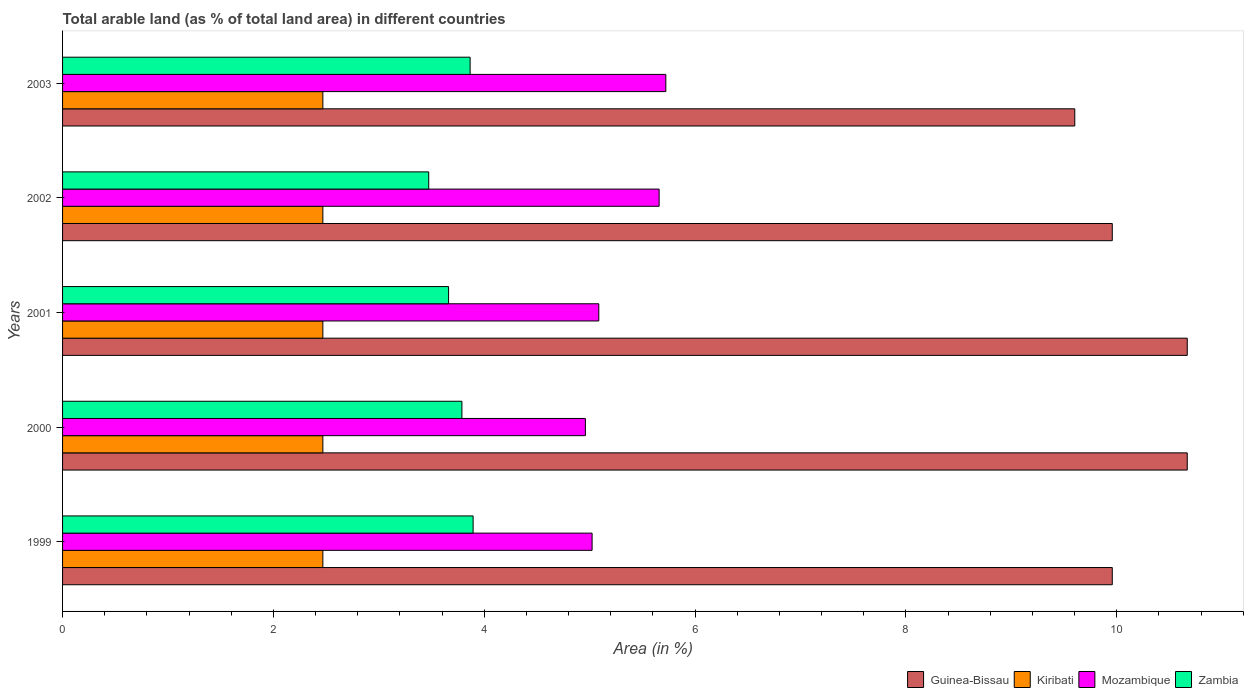How many groups of bars are there?
Give a very brief answer. 5. What is the label of the 5th group of bars from the top?
Provide a succinct answer. 1999. In how many cases, is the number of bars for a given year not equal to the number of legend labels?
Give a very brief answer. 0. What is the percentage of arable land in Kiribati in 2002?
Make the answer very short. 2.47. Across all years, what is the maximum percentage of arable land in Zambia?
Make the answer very short. 3.89. Across all years, what is the minimum percentage of arable land in Mozambique?
Make the answer very short. 4.96. In which year was the percentage of arable land in Zambia maximum?
Provide a short and direct response. 1999. In which year was the percentage of arable land in Zambia minimum?
Offer a very short reply. 2002. What is the total percentage of arable land in Mozambique in the graph?
Your answer should be very brief. 26.45. What is the difference between the percentage of arable land in Kiribati in 2002 and that in 2003?
Make the answer very short. 0. What is the difference between the percentage of arable land in Kiribati in 2000 and the percentage of arable land in Zambia in 1999?
Provide a succinct answer. -1.43. What is the average percentage of arable land in Zambia per year?
Your answer should be very brief. 3.74. In the year 2001, what is the difference between the percentage of arable land in Guinea-Bissau and percentage of arable land in Kiribati?
Ensure brevity in your answer.  8.2. In how many years, is the percentage of arable land in Guinea-Bissau greater than 5.6 %?
Offer a terse response. 5. Is the difference between the percentage of arable land in Guinea-Bissau in 1999 and 2001 greater than the difference between the percentage of arable land in Kiribati in 1999 and 2001?
Your response must be concise. No. What is the difference between the highest and the lowest percentage of arable land in Mozambique?
Give a very brief answer. 0.76. What does the 1st bar from the top in 2002 represents?
Make the answer very short. Zambia. What does the 3rd bar from the bottom in 2000 represents?
Provide a succinct answer. Mozambique. How many bars are there?
Offer a very short reply. 20. Are all the bars in the graph horizontal?
Keep it short and to the point. Yes. How many years are there in the graph?
Your answer should be very brief. 5. What is the difference between two consecutive major ticks on the X-axis?
Make the answer very short. 2. Does the graph contain grids?
Offer a very short reply. No. How are the legend labels stacked?
Provide a succinct answer. Horizontal. What is the title of the graph?
Ensure brevity in your answer.  Total arable land (as % of total land area) in different countries. What is the label or title of the X-axis?
Ensure brevity in your answer.  Area (in %). What is the label or title of the Y-axis?
Ensure brevity in your answer.  Years. What is the Area (in %) of Guinea-Bissau in 1999?
Keep it short and to the point. 9.96. What is the Area (in %) in Kiribati in 1999?
Your answer should be compact. 2.47. What is the Area (in %) of Mozambique in 1999?
Offer a terse response. 5.02. What is the Area (in %) of Zambia in 1999?
Ensure brevity in your answer.  3.89. What is the Area (in %) of Guinea-Bissau in 2000?
Provide a succinct answer. 10.67. What is the Area (in %) in Kiribati in 2000?
Give a very brief answer. 2.47. What is the Area (in %) of Mozambique in 2000?
Give a very brief answer. 4.96. What is the Area (in %) of Zambia in 2000?
Offer a very short reply. 3.79. What is the Area (in %) of Guinea-Bissau in 2001?
Your response must be concise. 10.67. What is the Area (in %) in Kiribati in 2001?
Give a very brief answer. 2.47. What is the Area (in %) in Mozambique in 2001?
Your response must be concise. 5.09. What is the Area (in %) in Zambia in 2001?
Ensure brevity in your answer.  3.66. What is the Area (in %) of Guinea-Bissau in 2002?
Make the answer very short. 9.96. What is the Area (in %) of Kiribati in 2002?
Give a very brief answer. 2.47. What is the Area (in %) in Mozambique in 2002?
Your response must be concise. 5.66. What is the Area (in %) in Zambia in 2002?
Offer a very short reply. 3.47. What is the Area (in %) of Guinea-Bissau in 2003?
Offer a terse response. 9.6. What is the Area (in %) of Kiribati in 2003?
Offer a terse response. 2.47. What is the Area (in %) of Mozambique in 2003?
Your answer should be very brief. 5.72. What is the Area (in %) of Zambia in 2003?
Provide a succinct answer. 3.87. Across all years, what is the maximum Area (in %) of Guinea-Bissau?
Offer a terse response. 10.67. Across all years, what is the maximum Area (in %) in Kiribati?
Make the answer very short. 2.47. Across all years, what is the maximum Area (in %) of Mozambique?
Your response must be concise. 5.72. Across all years, what is the maximum Area (in %) in Zambia?
Ensure brevity in your answer.  3.89. Across all years, what is the minimum Area (in %) of Guinea-Bissau?
Your response must be concise. 9.6. Across all years, what is the minimum Area (in %) in Kiribati?
Provide a succinct answer. 2.47. Across all years, what is the minimum Area (in %) in Mozambique?
Ensure brevity in your answer.  4.96. Across all years, what is the minimum Area (in %) in Zambia?
Your answer should be compact. 3.47. What is the total Area (in %) in Guinea-Bissau in the graph?
Provide a succinct answer. 50.85. What is the total Area (in %) in Kiribati in the graph?
Ensure brevity in your answer.  12.35. What is the total Area (in %) of Mozambique in the graph?
Provide a short and direct response. 26.45. What is the total Area (in %) of Zambia in the graph?
Make the answer very short. 18.68. What is the difference between the Area (in %) in Guinea-Bissau in 1999 and that in 2000?
Ensure brevity in your answer.  -0.71. What is the difference between the Area (in %) in Mozambique in 1999 and that in 2000?
Your answer should be very brief. 0.06. What is the difference between the Area (in %) in Zambia in 1999 and that in 2000?
Ensure brevity in your answer.  0.11. What is the difference between the Area (in %) in Guinea-Bissau in 1999 and that in 2001?
Offer a terse response. -0.71. What is the difference between the Area (in %) of Mozambique in 1999 and that in 2001?
Your answer should be very brief. -0.06. What is the difference between the Area (in %) of Zambia in 1999 and that in 2001?
Provide a succinct answer. 0.23. What is the difference between the Area (in %) of Mozambique in 1999 and that in 2002?
Offer a terse response. -0.64. What is the difference between the Area (in %) in Zambia in 1999 and that in 2002?
Provide a succinct answer. 0.42. What is the difference between the Area (in %) in Guinea-Bissau in 1999 and that in 2003?
Give a very brief answer. 0.36. What is the difference between the Area (in %) in Kiribati in 1999 and that in 2003?
Your response must be concise. 0. What is the difference between the Area (in %) in Mozambique in 1999 and that in 2003?
Your answer should be compact. -0.7. What is the difference between the Area (in %) of Zambia in 1999 and that in 2003?
Your answer should be compact. 0.03. What is the difference between the Area (in %) in Mozambique in 2000 and that in 2001?
Make the answer very short. -0.13. What is the difference between the Area (in %) of Zambia in 2000 and that in 2001?
Ensure brevity in your answer.  0.13. What is the difference between the Area (in %) in Guinea-Bissau in 2000 and that in 2002?
Offer a very short reply. 0.71. What is the difference between the Area (in %) in Kiribati in 2000 and that in 2002?
Provide a succinct answer. 0. What is the difference between the Area (in %) in Mozambique in 2000 and that in 2002?
Your response must be concise. -0.7. What is the difference between the Area (in %) in Zambia in 2000 and that in 2002?
Keep it short and to the point. 0.31. What is the difference between the Area (in %) of Guinea-Bissau in 2000 and that in 2003?
Offer a very short reply. 1.07. What is the difference between the Area (in %) in Mozambique in 2000 and that in 2003?
Offer a terse response. -0.76. What is the difference between the Area (in %) in Zambia in 2000 and that in 2003?
Ensure brevity in your answer.  -0.08. What is the difference between the Area (in %) in Guinea-Bissau in 2001 and that in 2002?
Ensure brevity in your answer.  0.71. What is the difference between the Area (in %) in Mozambique in 2001 and that in 2002?
Provide a short and direct response. -0.57. What is the difference between the Area (in %) of Zambia in 2001 and that in 2002?
Offer a terse response. 0.19. What is the difference between the Area (in %) of Guinea-Bissau in 2001 and that in 2003?
Keep it short and to the point. 1.07. What is the difference between the Area (in %) of Mozambique in 2001 and that in 2003?
Offer a terse response. -0.64. What is the difference between the Area (in %) in Zambia in 2001 and that in 2003?
Provide a short and direct response. -0.2. What is the difference between the Area (in %) in Guinea-Bissau in 2002 and that in 2003?
Ensure brevity in your answer.  0.36. What is the difference between the Area (in %) of Kiribati in 2002 and that in 2003?
Provide a short and direct response. 0. What is the difference between the Area (in %) in Mozambique in 2002 and that in 2003?
Your answer should be compact. -0.06. What is the difference between the Area (in %) of Zambia in 2002 and that in 2003?
Make the answer very short. -0.39. What is the difference between the Area (in %) in Guinea-Bissau in 1999 and the Area (in %) in Kiribati in 2000?
Provide a short and direct response. 7.49. What is the difference between the Area (in %) of Guinea-Bissau in 1999 and the Area (in %) of Mozambique in 2000?
Offer a very short reply. 5. What is the difference between the Area (in %) in Guinea-Bissau in 1999 and the Area (in %) in Zambia in 2000?
Give a very brief answer. 6.17. What is the difference between the Area (in %) in Kiribati in 1999 and the Area (in %) in Mozambique in 2000?
Make the answer very short. -2.49. What is the difference between the Area (in %) of Kiribati in 1999 and the Area (in %) of Zambia in 2000?
Your answer should be very brief. -1.32. What is the difference between the Area (in %) in Mozambique in 1999 and the Area (in %) in Zambia in 2000?
Keep it short and to the point. 1.24. What is the difference between the Area (in %) in Guinea-Bissau in 1999 and the Area (in %) in Kiribati in 2001?
Give a very brief answer. 7.49. What is the difference between the Area (in %) of Guinea-Bissau in 1999 and the Area (in %) of Mozambique in 2001?
Make the answer very short. 4.87. What is the difference between the Area (in %) of Guinea-Bissau in 1999 and the Area (in %) of Zambia in 2001?
Offer a very short reply. 6.3. What is the difference between the Area (in %) in Kiribati in 1999 and the Area (in %) in Mozambique in 2001?
Offer a very short reply. -2.62. What is the difference between the Area (in %) in Kiribati in 1999 and the Area (in %) in Zambia in 2001?
Offer a very short reply. -1.19. What is the difference between the Area (in %) of Mozambique in 1999 and the Area (in %) of Zambia in 2001?
Your response must be concise. 1.36. What is the difference between the Area (in %) of Guinea-Bissau in 1999 and the Area (in %) of Kiribati in 2002?
Offer a very short reply. 7.49. What is the difference between the Area (in %) of Guinea-Bissau in 1999 and the Area (in %) of Mozambique in 2002?
Provide a short and direct response. 4.3. What is the difference between the Area (in %) of Guinea-Bissau in 1999 and the Area (in %) of Zambia in 2002?
Ensure brevity in your answer.  6.48. What is the difference between the Area (in %) in Kiribati in 1999 and the Area (in %) in Mozambique in 2002?
Offer a very short reply. -3.19. What is the difference between the Area (in %) in Kiribati in 1999 and the Area (in %) in Zambia in 2002?
Offer a very short reply. -1. What is the difference between the Area (in %) in Mozambique in 1999 and the Area (in %) in Zambia in 2002?
Ensure brevity in your answer.  1.55. What is the difference between the Area (in %) in Guinea-Bissau in 1999 and the Area (in %) in Kiribati in 2003?
Provide a short and direct response. 7.49. What is the difference between the Area (in %) in Guinea-Bissau in 1999 and the Area (in %) in Mozambique in 2003?
Provide a short and direct response. 4.23. What is the difference between the Area (in %) in Guinea-Bissau in 1999 and the Area (in %) in Zambia in 2003?
Make the answer very short. 6.09. What is the difference between the Area (in %) in Kiribati in 1999 and the Area (in %) in Mozambique in 2003?
Provide a short and direct response. -3.25. What is the difference between the Area (in %) of Kiribati in 1999 and the Area (in %) of Zambia in 2003?
Offer a terse response. -1.4. What is the difference between the Area (in %) of Mozambique in 1999 and the Area (in %) of Zambia in 2003?
Offer a terse response. 1.16. What is the difference between the Area (in %) in Guinea-Bissau in 2000 and the Area (in %) in Kiribati in 2001?
Keep it short and to the point. 8.2. What is the difference between the Area (in %) in Guinea-Bissau in 2000 and the Area (in %) in Mozambique in 2001?
Make the answer very short. 5.58. What is the difference between the Area (in %) in Guinea-Bissau in 2000 and the Area (in %) in Zambia in 2001?
Offer a terse response. 7.01. What is the difference between the Area (in %) of Kiribati in 2000 and the Area (in %) of Mozambique in 2001?
Offer a terse response. -2.62. What is the difference between the Area (in %) of Kiribati in 2000 and the Area (in %) of Zambia in 2001?
Keep it short and to the point. -1.19. What is the difference between the Area (in %) of Mozambique in 2000 and the Area (in %) of Zambia in 2001?
Your response must be concise. 1.3. What is the difference between the Area (in %) in Guinea-Bissau in 2000 and the Area (in %) in Kiribati in 2002?
Offer a very short reply. 8.2. What is the difference between the Area (in %) in Guinea-Bissau in 2000 and the Area (in %) in Mozambique in 2002?
Keep it short and to the point. 5.01. What is the difference between the Area (in %) of Guinea-Bissau in 2000 and the Area (in %) of Zambia in 2002?
Ensure brevity in your answer.  7.2. What is the difference between the Area (in %) of Kiribati in 2000 and the Area (in %) of Mozambique in 2002?
Your answer should be compact. -3.19. What is the difference between the Area (in %) in Kiribati in 2000 and the Area (in %) in Zambia in 2002?
Offer a terse response. -1. What is the difference between the Area (in %) in Mozambique in 2000 and the Area (in %) in Zambia in 2002?
Your response must be concise. 1.49. What is the difference between the Area (in %) of Guinea-Bissau in 2000 and the Area (in %) of Kiribati in 2003?
Give a very brief answer. 8.2. What is the difference between the Area (in %) in Guinea-Bissau in 2000 and the Area (in %) in Mozambique in 2003?
Your answer should be compact. 4.95. What is the difference between the Area (in %) in Guinea-Bissau in 2000 and the Area (in %) in Zambia in 2003?
Provide a short and direct response. 6.8. What is the difference between the Area (in %) in Kiribati in 2000 and the Area (in %) in Mozambique in 2003?
Your answer should be very brief. -3.25. What is the difference between the Area (in %) of Kiribati in 2000 and the Area (in %) of Zambia in 2003?
Provide a succinct answer. -1.4. What is the difference between the Area (in %) in Mozambique in 2000 and the Area (in %) in Zambia in 2003?
Offer a very short reply. 1.09. What is the difference between the Area (in %) of Guinea-Bissau in 2001 and the Area (in %) of Kiribati in 2002?
Provide a short and direct response. 8.2. What is the difference between the Area (in %) in Guinea-Bissau in 2001 and the Area (in %) in Mozambique in 2002?
Your answer should be very brief. 5.01. What is the difference between the Area (in %) of Guinea-Bissau in 2001 and the Area (in %) of Zambia in 2002?
Offer a terse response. 7.2. What is the difference between the Area (in %) in Kiribati in 2001 and the Area (in %) in Mozambique in 2002?
Make the answer very short. -3.19. What is the difference between the Area (in %) in Kiribati in 2001 and the Area (in %) in Zambia in 2002?
Give a very brief answer. -1. What is the difference between the Area (in %) in Mozambique in 2001 and the Area (in %) in Zambia in 2002?
Give a very brief answer. 1.61. What is the difference between the Area (in %) of Guinea-Bissau in 2001 and the Area (in %) of Kiribati in 2003?
Give a very brief answer. 8.2. What is the difference between the Area (in %) in Guinea-Bissau in 2001 and the Area (in %) in Mozambique in 2003?
Offer a terse response. 4.95. What is the difference between the Area (in %) in Guinea-Bissau in 2001 and the Area (in %) in Zambia in 2003?
Offer a terse response. 6.8. What is the difference between the Area (in %) in Kiribati in 2001 and the Area (in %) in Mozambique in 2003?
Provide a succinct answer. -3.25. What is the difference between the Area (in %) of Kiribati in 2001 and the Area (in %) of Zambia in 2003?
Provide a short and direct response. -1.4. What is the difference between the Area (in %) in Mozambique in 2001 and the Area (in %) in Zambia in 2003?
Provide a succinct answer. 1.22. What is the difference between the Area (in %) of Guinea-Bissau in 2002 and the Area (in %) of Kiribati in 2003?
Offer a very short reply. 7.49. What is the difference between the Area (in %) in Guinea-Bissau in 2002 and the Area (in %) in Mozambique in 2003?
Make the answer very short. 4.23. What is the difference between the Area (in %) in Guinea-Bissau in 2002 and the Area (in %) in Zambia in 2003?
Your response must be concise. 6.09. What is the difference between the Area (in %) of Kiribati in 2002 and the Area (in %) of Mozambique in 2003?
Offer a very short reply. -3.25. What is the difference between the Area (in %) in Kiribati in 2002 and the Area (in %) in Zambia in 2003?
Give a very brief answer. -1.4. What is the difference between the Area (in %) in Mozambique in 2002 and the Area (in %) in Zambia in 2003?
Ensure brevity in your answer.  1.79. What is the average Area (in %) in Guinea-Bissau per year?
Your answer should be compact. 10.17. What is the average Area (in %) in Kiribati per year?
Make the answer very short. 2.47. What is the average Area (in %) of Mozambique per year?
Make the answer very short. 5.29. What is the average Area (in %) of Zambia per year?
Offer a terse response. 3.74. In the year 1999, what is the difference between the Area (in %) of Guinea-Bissau and Area (in %) of Kiribati?
Provide a short and direct response. 7.49. In the year 1999, what is the difference between the Area (in %) of Guinea-Bissau and Area (in %) of Mozambique?
Your answer should be very brief. 4.93. In the year 1999, what is the difference between the Area (in %) in Guinea-Bissau and Area (in %) in Zambia?
Your answer should be compact. 6.06. In the year 1999, what is the difference between the Area (in %) in Kiribati and Area (in %) in Mozambique?
Give a very brief answer. -2.55. In the year 1999, what is the difference between the Area (in %) of Kiribati and Area (in %) of Zambia?
Provide a succinct answer. -1.43. In the year 1999, what is the difference between the Area (in %) in Mozambique and Area (in %) in Zambia?
Offer a very short reply. 1.13. In the year 2000, what is the difference between the Area (in %) in Guinea-Bissau and Area (in %) in Kiribati?
Make the answer very short. 8.2. In the year 2000, what is the difference between the Area (in %) in Guinea-Bissau and Area (in %) in Mozambique?
Provide a succinct answer. 5.71. In the year 2000, what is the difference between the Area (in %) in Guinea-Bissau and Area (in %) in Zambia?
Provide a short and direct response. 6.88. In the year 2000, what is the difference between the Area (in %) of Kiribati and Area (in %) of Mozambique?
Make the answer very short. -2.49. In the year 2000, what is the difference between the Area (in %) of Kiribati and Area (in %) of Zambia?
Your answer should be very brief. -1.32. In the year 2000, what is the difference between the Area (in %) in Mozambique and Area (in %) in Zambia?
Give a very brief answer. 1.17. In the year 2001, what is the difference between the Area (in %) in Guinea-Bissau and Area (in %) in Kiribati?
Provide a short and direct response. 8.2. In the year 2001, what is the difference between the Area (in %) in Guinea-Bissau and Area (in %) in Mozambique?
Offer a very short reply. 5.58. In the year 2001, what is the difference between the Area (in %) of Guinea-Bissau and Area (in %) of Zambia?
Keep it short and to the point. 7.01. In the year 2001, what is the difference between the Area (in %) in Kiribati and Area (in %) in Mozambique?
Your answer should be very brief. -2.62. In the year 2001, what is the difference between the Area (in %) in Kiribati and Area (in %) in Zambia?
Your answer should be compact. -1.19. In the year 2001, what is the difference between the Area (in %) of Mozambique and Area (in %) of Zambia?
Provide a short and direct response. 1.43. In the year 2002, what is the difference between the Area (in %) of Guinea-Bissau and Area (in %) of Kiribati?
Make the answer very short. 7.49. In the year 2002, what is the difference between the Area (in %) in Guinea-Bissau and Area (in %) in Mozambique?
Provide a short and direct response. 4.3. In the year 2002, what is the difference between the Area (in %) of Guinea-Bissau and Area (in %) of Zambia?
Offer a very short reply. 6.48. In the year 2002, what is the difference between the Area (in %) of Kiribati and Area (in %) of Mozambique?
Your answer should be very brief. -3.19. In the year 2002, what is the difference between the Area (in %) in Kiribati and Area (in %) in Zambia?
Give a very brief answer. -1. In the year 2002, what is the difference between the Area (in %) in Mozambique and Area (in %) in Zambia?
Keep it short and to the point. 2.19. In the year 2003, what is the difference between the Area (in %) of Guinea-Bissau and Area (in %) of Kiribati?
Provide a succinct answer. 7.13. In the year 2003, what is the difference between the Area (in %) of Guinea-Bissau and Area (in %) of Mozambique?
Give a very brief answer. 3.88. In the year 2003, what is the difference between the Area (in %) in Guinea-Bissau and Area (in %) in Zambia?
Give a very brief answer. 5.74. In the year 2003, what is the difference between the Area (in %) of Kiribati and Area (in %) of Mozambique?
Make the answer very short. -3.25. In the year 2003, what is the difference between the Area (in %) of Kiribati and Area (in %) of Zambia?
Make the answer very short. -1.4. In the year 2003, what is the difference between the Area (in %) of Mozambique and Area (in %) of Zambia?
Give a very brief answer. 1.86. What is the ratio of the Area (in %) of Mozambique in 1999 to that in 2000?
Make the answer very short. 1.01. What is the ratio of the Area (in %) in Zambia in 1999 to that in 2000?
Provide a short and direct response. 1.03. What is the ratio of the Area (in %) in Mozambique in 1999 to that in 2001?
Provide a short and direct response. 0.99. What is the ratio of the Area (in %) in Zambia in 1999 to that in 2001?
Provide a succinct answer. 1.06. What is the ratio of the Area (in %) in Guinea-Bissau in 1999 to that in 2002?
Give a very brief answer. 1. What is the ratio of the Area (in %) of Kiribati in 1999 to that in 2002?
Provide a succinct answer. 1. What is the ratio of the Area (in %) in Mozambique in 1999 to that in 2002?
Ensure brevity in your answer.  0.89. What is the ratio of the Area (in %) in Zambia in 1999 to that in 2002?
Your answer should be compact. 1.12. What is the ratio of the Area (in %) of Guinea-Bissau in 1999 to that in 2003?
Your answer should be very brief. 1.04. What is the ratio of the Area (in %) of Mozambique in 1999 to that in 2003?
Keep it short and to the point. 0.88. What is the ratio of the Area (in %) of Zambia in 1999 to that in 2003?
Your response must be concise. 1.01. What is the ratio of the Area (in %) in Guinea-Bissau in 2000 to that in 2001?
Provide a succinct answer. 1. What is the ratio of the Area (in %) of Kiribati in 2000 to that in 2001?
Offer a very short reply. 1. What is the ratio of the Area (in %) in Mozambique in 2000 to that in 2001?
Provide a short and direct response. 0.97. What is the ratio of the Area (in %) in Zambia in 2000 to that in 2001?
Your response must be concise. 1.03. What is the ratio of the Area (in %) in Guinea-Bissau in 2000 to that in 2002?
Offer a terse response. 1.07. What is the ratio of the Area (in %) of Kiribati in 2000 to that in 2002?
Your answer should be very brief. 1. What is the ratio of the Area (in %) of Mozambique in 2000 to that in 2002?
Keep it short and to the point. 0.88. What is the ratio of the Area (in %) of Zambia in 2000 to that in 2002?
Keep it short and to the point. 1.09. What is the ratio of the Area (in %) of Kiribati in 2000 to that in 2003?
Make the answer very short. 1. What is the ratio of the Area (in %) of Mozambique in 2000 to that in 2003?
Provide a short and direct response. 0.87. What is the ratio of the Area (in %) in Zambia in 2000 to that in 2003?
Your answer should be very brief. 0.98. What is the ratio of the Area (in %) of Guinea-Bissau in 2001 to that in 2002?
Provide a succinct answer. 1.07. What is the ratio of the Area (in %) in Kiribati in 2001 to that in 2002?
Your answer should be compact. 1. What is the ratio of the Area (in %) of Mozambique in 2001 to that in 2002?
Your response must be concise. 0.9. What is the ratio of the Area (in %) in Zambia in 2001 to that in 2002?
Ensure brevity in your answer.  1.05. What is the ratio of the Area (in %) of Guinea-Bissau in 2001 to that in 2003?
Provide a short and direct response. 1.11. What is the ratio of the Area (in %) of Kiribati in 2001 to that in 2003?
Ensure brevity in your answer.  1. What is the ratio of the Area (in %) in Mozambique in 2001 to that in 2003?
Offer a very short reply. 0.89. What is the ratio of the Area (in %) in Zambia in 2001 to that in 2003?
Keep it short and to the point. 0.95. What is the ratio of the Area (in %) in Kiribati in 2002 to that in 2003?
Offer a very short reply. 1. What is the ratio of the Area (in %) in Mozambique in 2002 to that in 2003?
Provide a short and direct response. 0.99. What is the ratio of the Area (in %) in Zambia in 2002 to that in 2003?
Your answer should be very brief. 0.9. What is the difference between the highest and the second highest Area (in %) of Kiribati?
Keep it short and to the point. 0. What is the difference between the highest and the second highest Area (in %) of Mozambique?
Offer a very short reply. 0.06. What is the difference between the highest and the second highest Area (in %) of Zambia?
Give a very brief answer. 0.03. What is the difference between the highest and the lowest Area (in %) in Guinea-Bissau?
Keep it short and to the point. 1.07. What is the difference between the highest and the lowest Area (in %) of Mozambique?
Make the answer very short. 0.76. What is the difference between the highest and the lowest Area (in %) of Zambia?
Your answer should be compact. 0.42. 